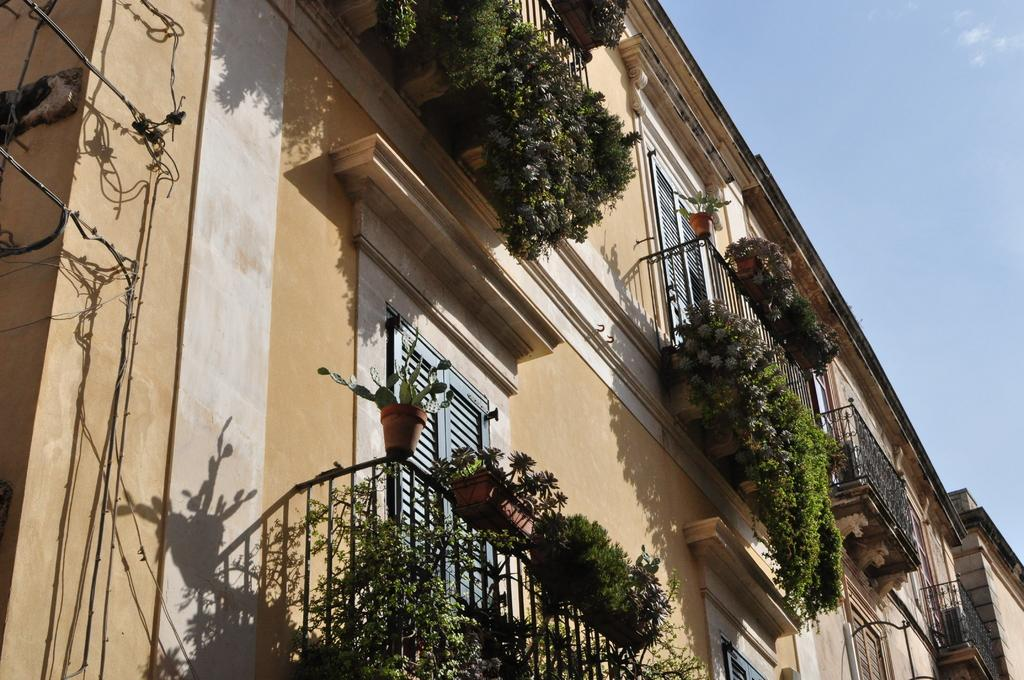What type of structure is present in the image? There is a building in the image. What feature can be seen on the building? The building has windows. What can be found near the balconies of the building? There are potted plants near the balconies. What is visible at the top of the image? The sky is visible at the top of the image. What is located on the left side of the image? There are wires on the left side of the image. What type of army is depicted in the image? There is no army present in the image; it features a building with windows, potted plants, and wires. How is the distribution of resources managed in the image? There is no information about resource distribution in the image; it only shows a building, windows, potted plants, the sky, and wires. 